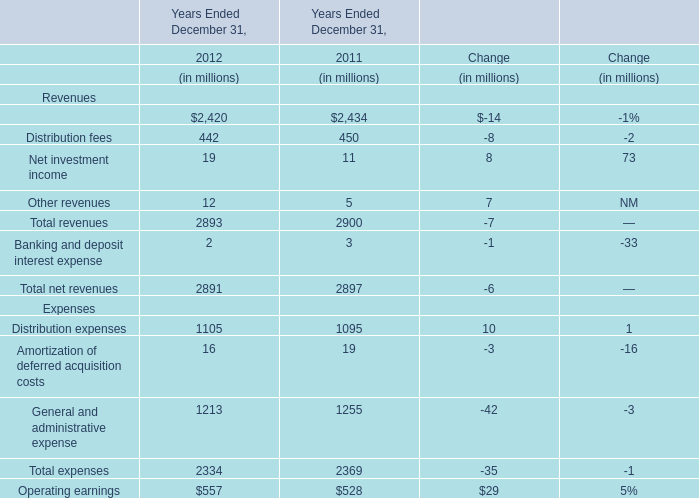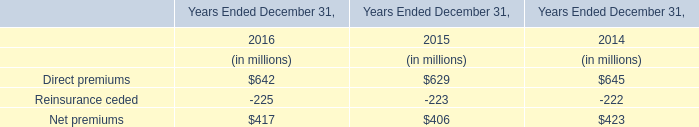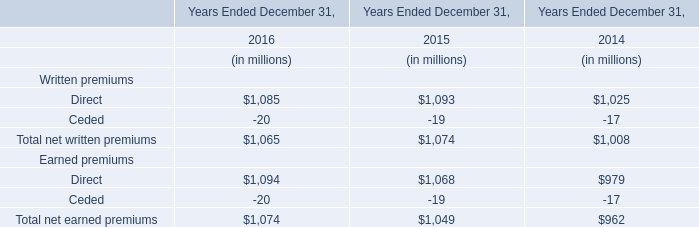what is the total yearly interest expense related to the notes issued in january 2016? 
Computations: ((400 * 2.00%) + (400 * 3.25%))
Answer: 21.0. 